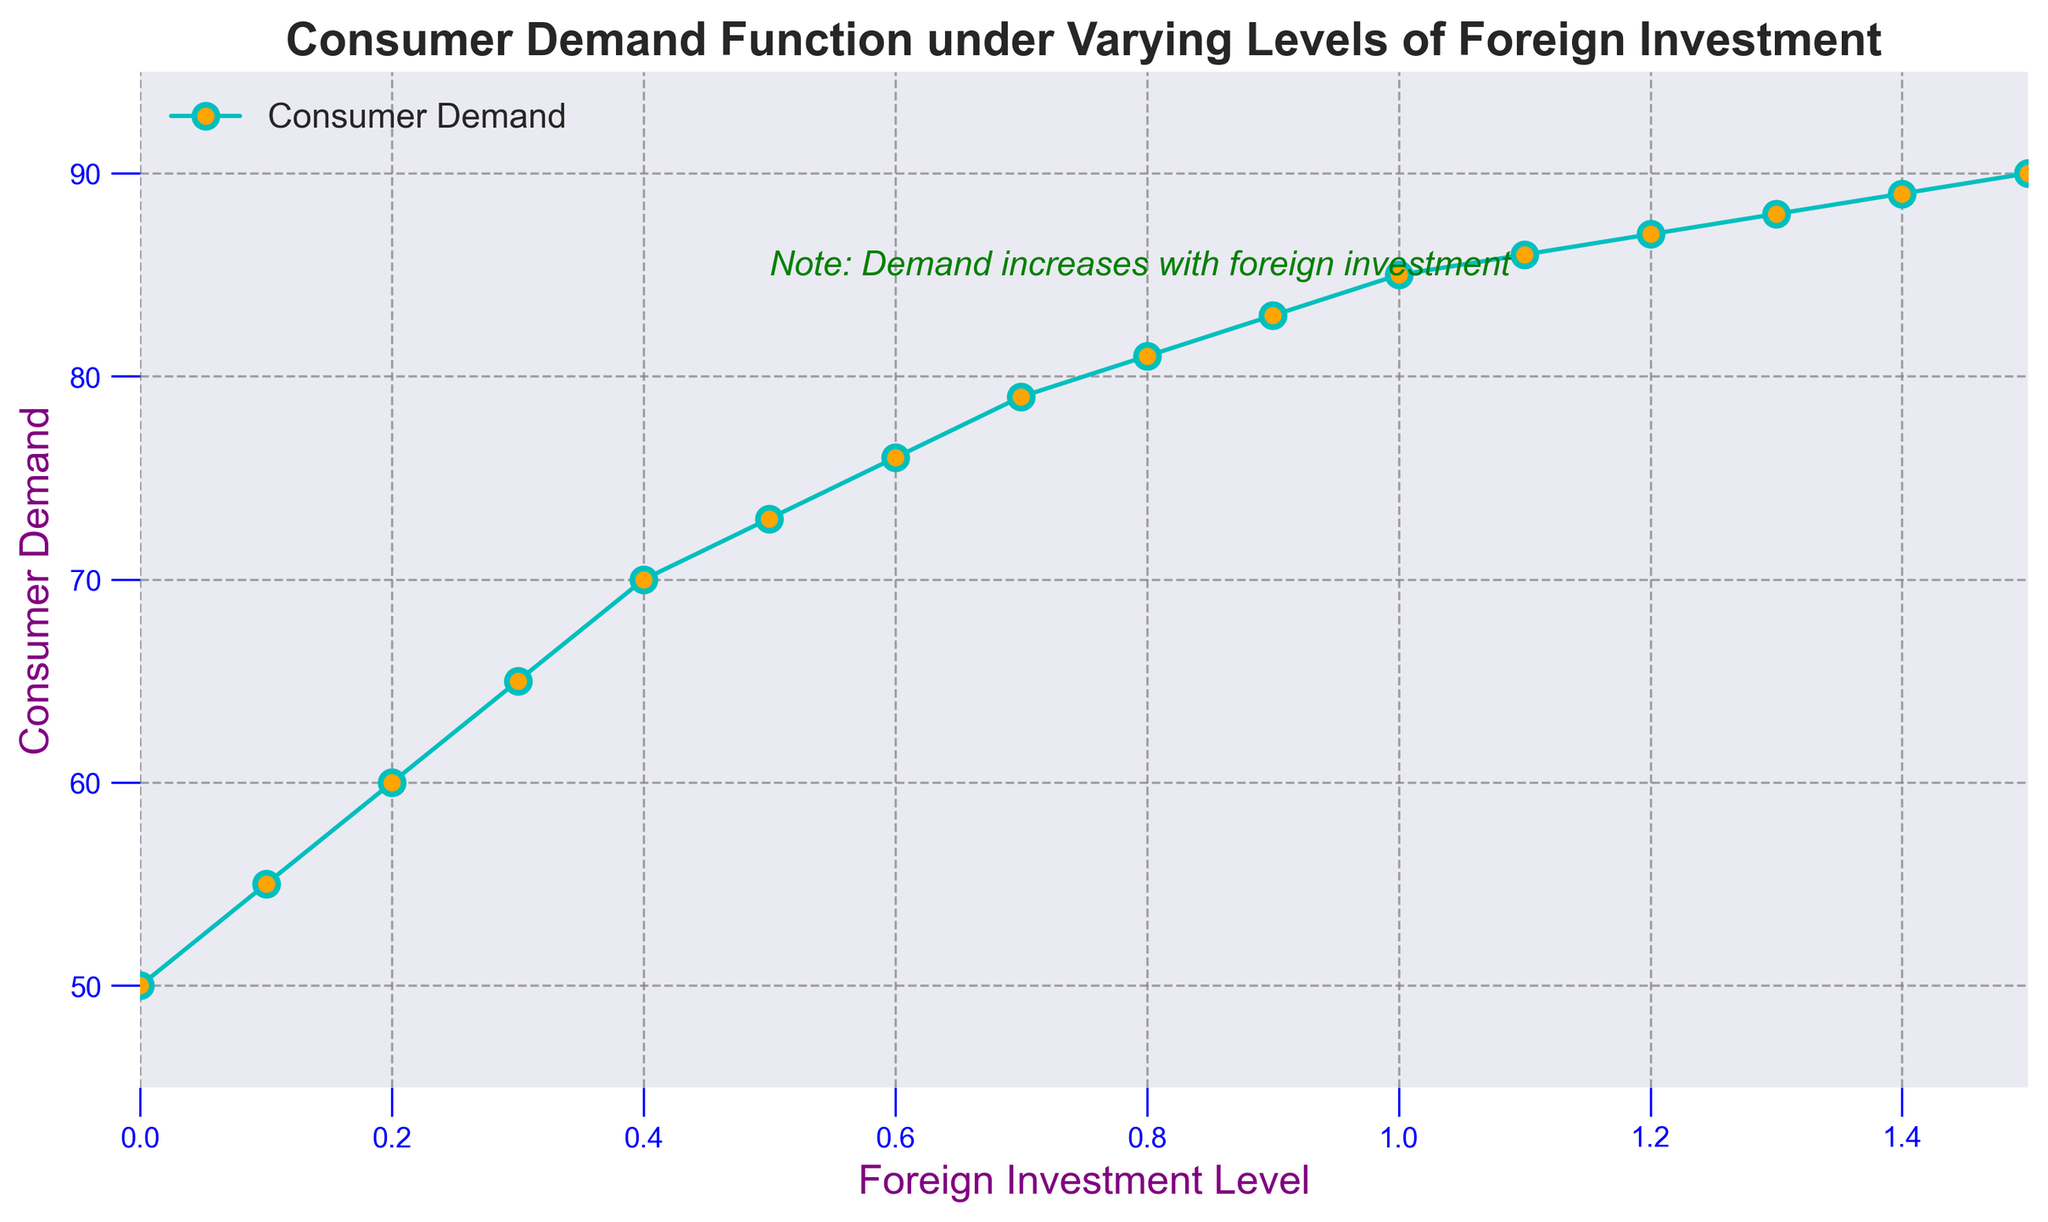Which level of Foreign Investment has the highest Consumer Demand? By examining the plot, we see that the highest point on the Consumer Demand curve corresponds to the level of Foreign Investment at 1.5, where the Consumer Demand is 90.
Answer: 1.5 What is the Consumer Demand when the Foreign Investment is 0.8? Looking at the figure, when Foreign Investment is at 0.8, the Consumer Demand value on the y-axis is 81.
Answer: 81 At which Foreign Investment level does Consumer Demand first exceed 85? Observing the plot, the Consumer Demand first exceeds 85 at a Foreign Investment level of 1.1.
Answer: 1.1 Is there a linear relationship between Foreign Investment and Consumer Demand? By examining the curve, it shows a generally increasing trend, but the rate of increase in Consumer Demand slows as Foreign Investment reaches higher levels, indicating it is not strictly linear.
Answer: No What is the difference in Consumer Demand between Foreign Investment levels of 0.5 and 0.9? From the figure, Consumer Demand at 0.5 is 73 and at 0.9 is 83. The difference is 83 - 73 = 10.
Answer: 10 What is the average Consumer Demand over the Foreign Investment levels of 0.3 and 0.7? Consumer Demand at 0.3 is 65, and at 0.7 it is 79. The average is (65 + 79) / 2 = 72.
Answer: 72 Does the Consumer Demand increase uniformly with Foreign Investment? Observing the plot, the increase in Consumer Demand is not uniform. The increments get smaller as Foreign Investment increases, indicating diminishing returns.
Answer: No At which level of Foreign Investment does the Consumer Demand plateau? Analyzing the plot, the Consumer Demand increase significantly slows down around 1.2 to 1.5, indicating a plateau.
Answer: 1.2 to 1.5 What color and type of line is used to represent Consumer Demand? Visually, the Consumer Demand is represented by a cyan (light blue) line with circular markers filled with orange.
Answer: Cyan line with orange markers 